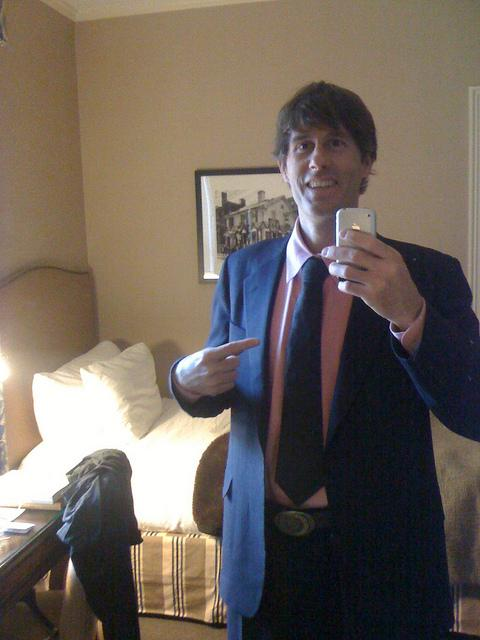What is the man doing?

Choices:
A) running
B) sleeping
C) pointing
D) eating pointing 